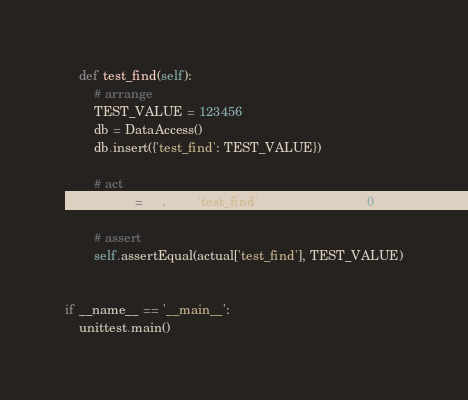Convert code to text. <code><loc_0><loc_0><loc_500><loc_500><_Python_>    def test_find(self):
        # arrange
        TEST_VALUE = 123456
        db = DataAccess()
        db.insert({'test_find': TEST_VALUE})

        # act
        actual = db.find({'test_find': TEST_VALUE})[0]

        # assert
        self.assertEqual(actual['test_find'], TEST_VALUE)


if __name__ == '__main__':
    unittest.main()
</code> 